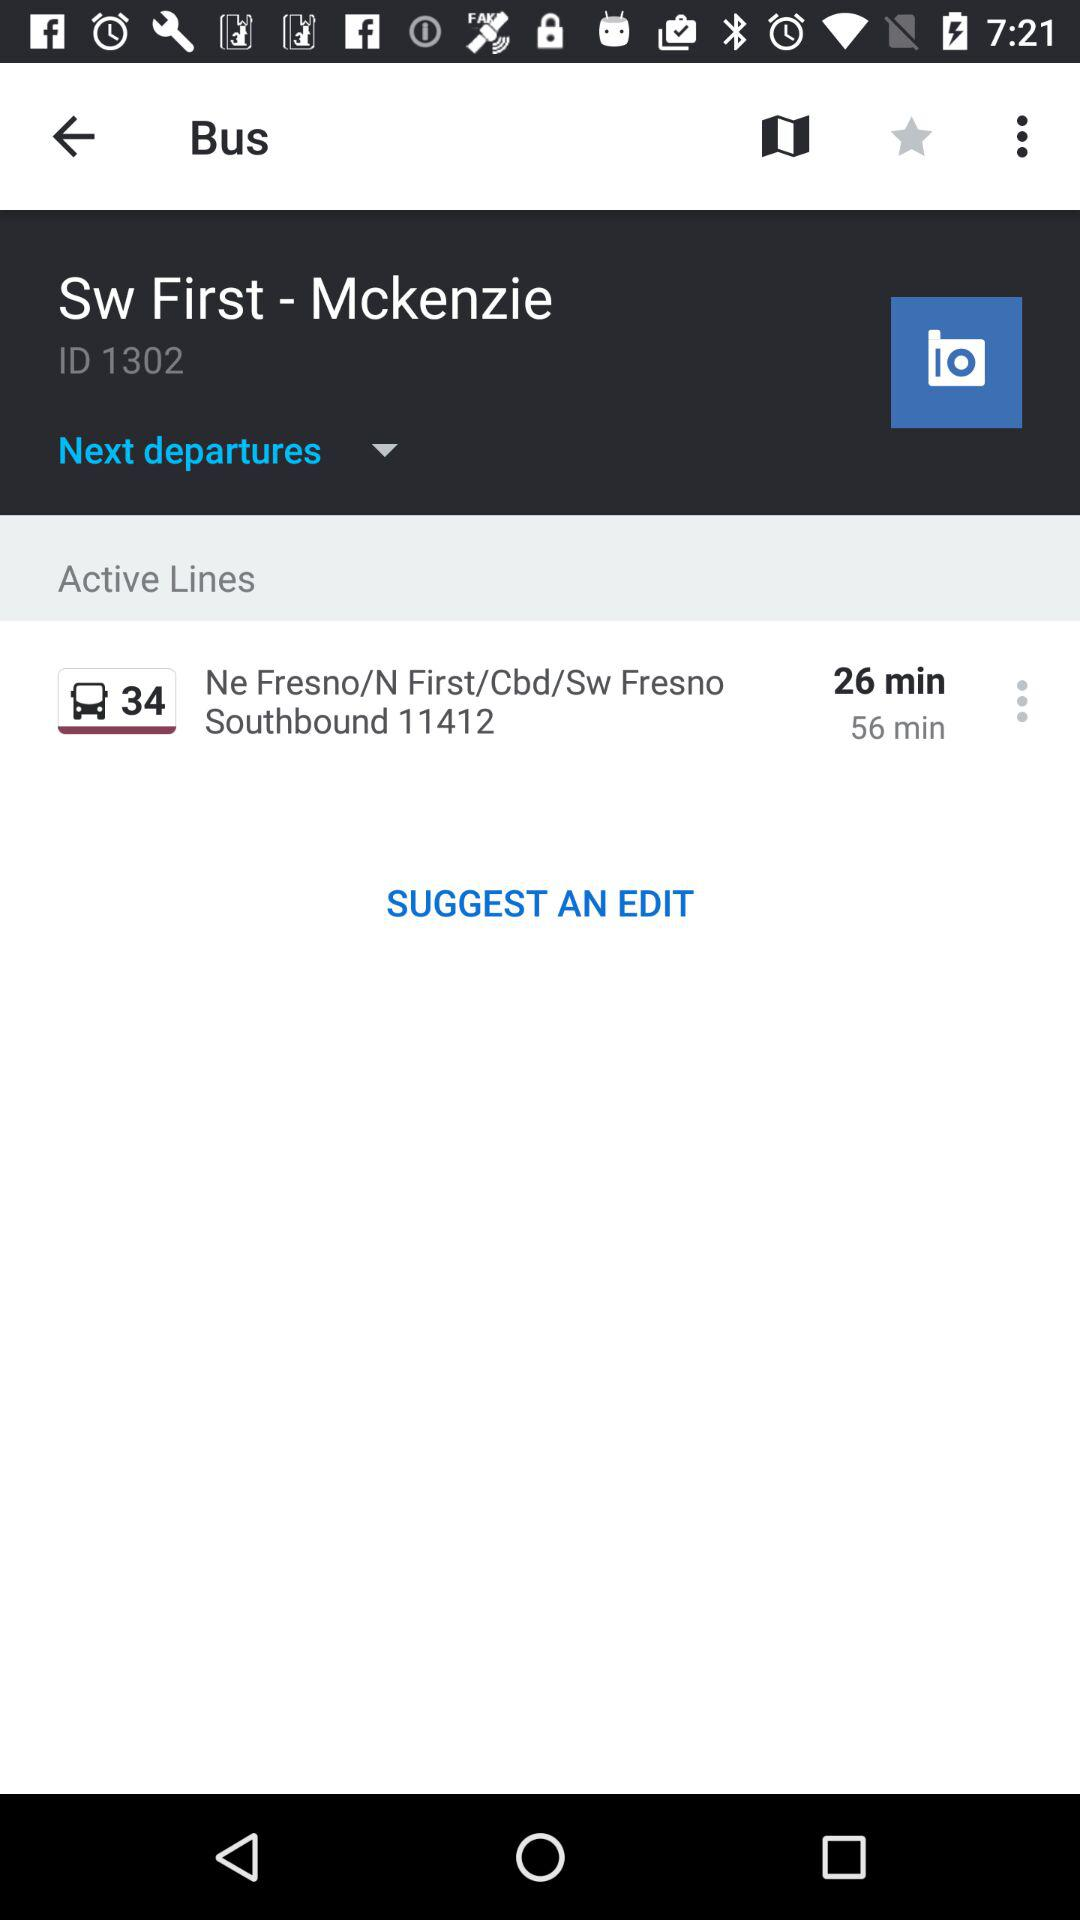What is the total time duration of this travel?
When the provided information is insufficient, respond with <no answer>. <no answer> 